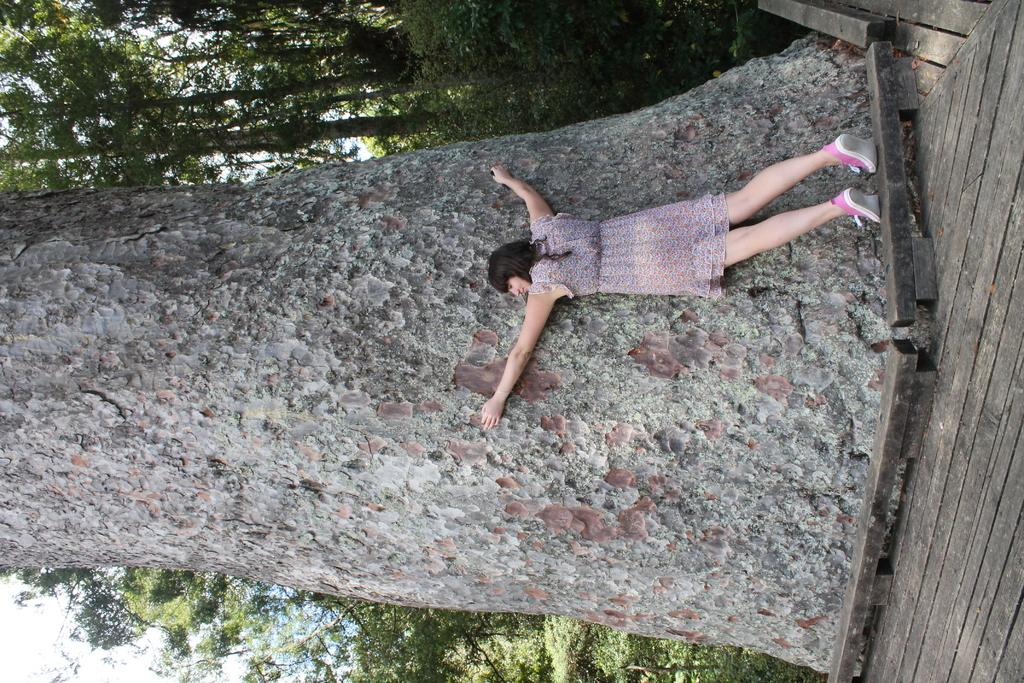Who is the main subject in the image? There is a lady in the image. What is the lady doing in the image? The lady is hugging a big tree trunk. What can be seen in the background of the image? There are trees in the background of the image. What type of watch is the lady wearing in the image? There is no watch visible on the lady in the image. Can you see any monkeys interacting with the lady in the image? There are no monkeys present in the image. 